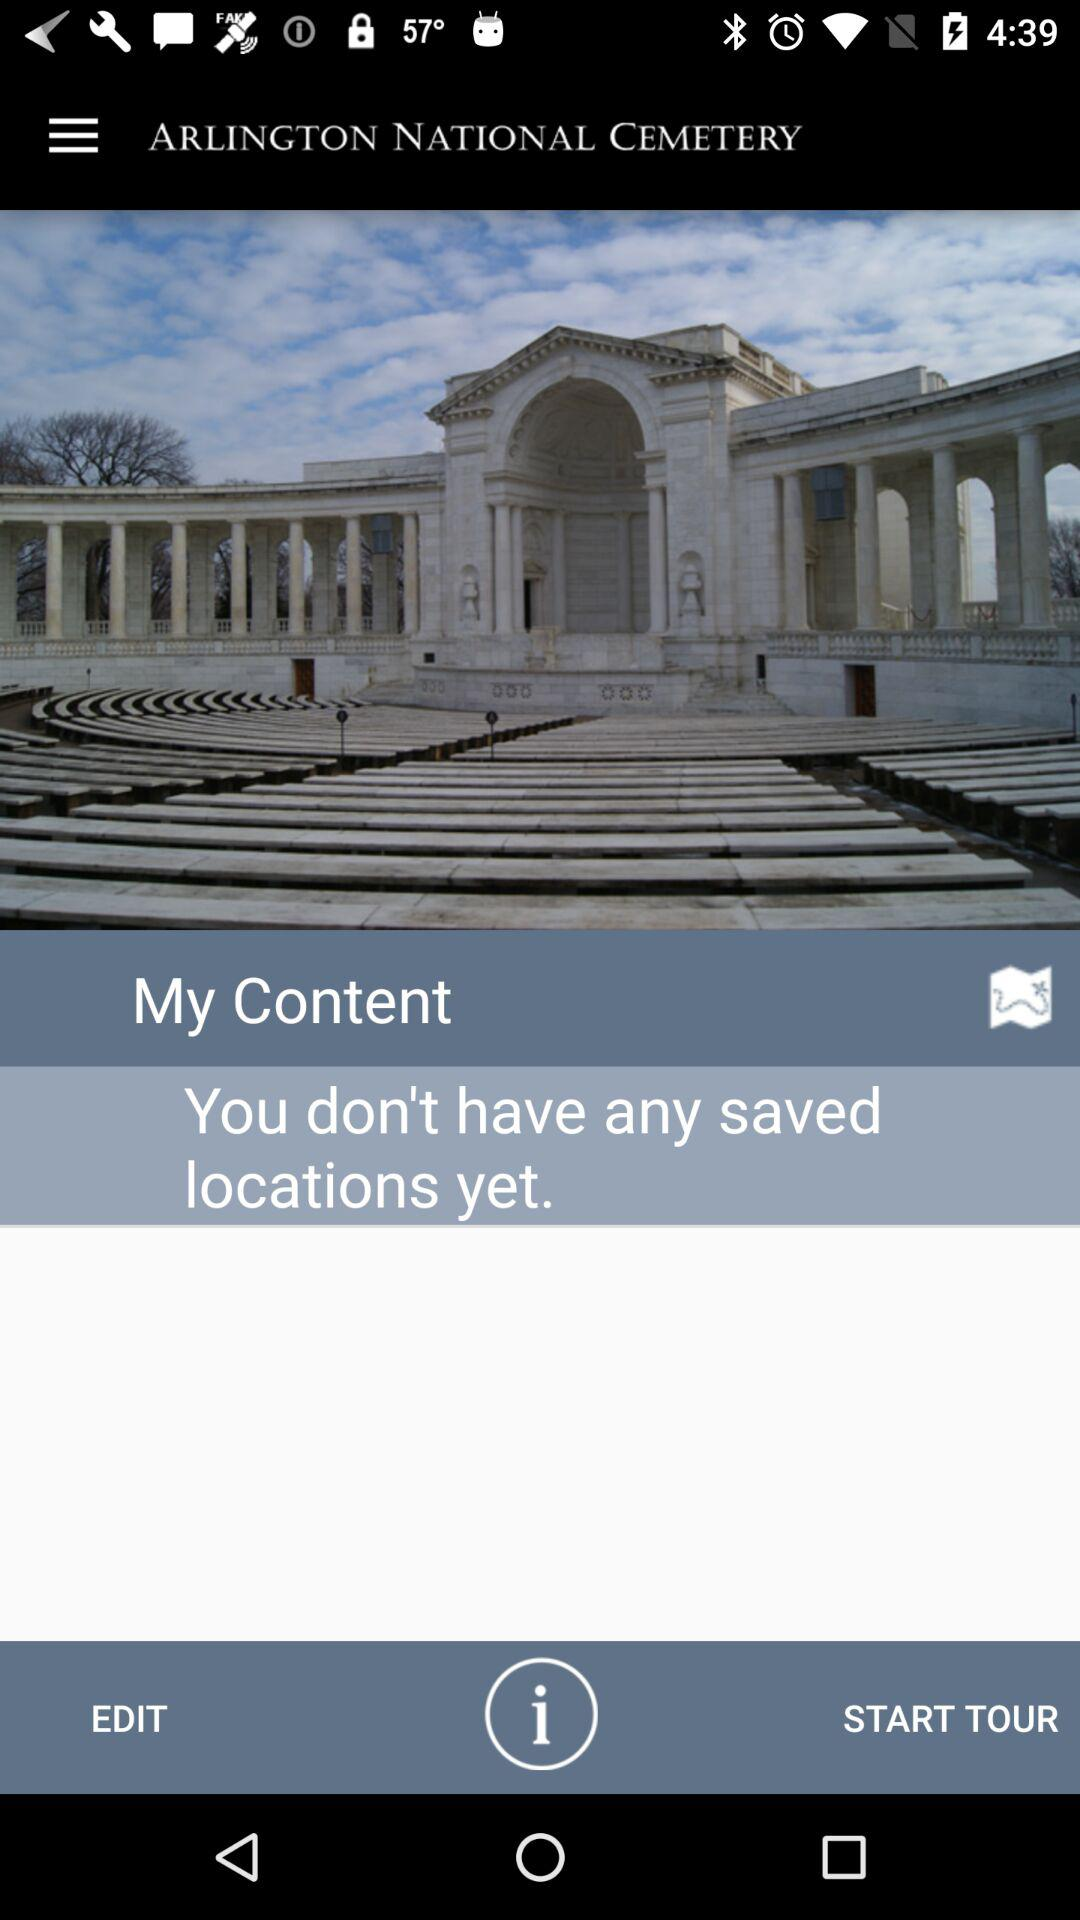Is there any saved location? There is no saved location. 